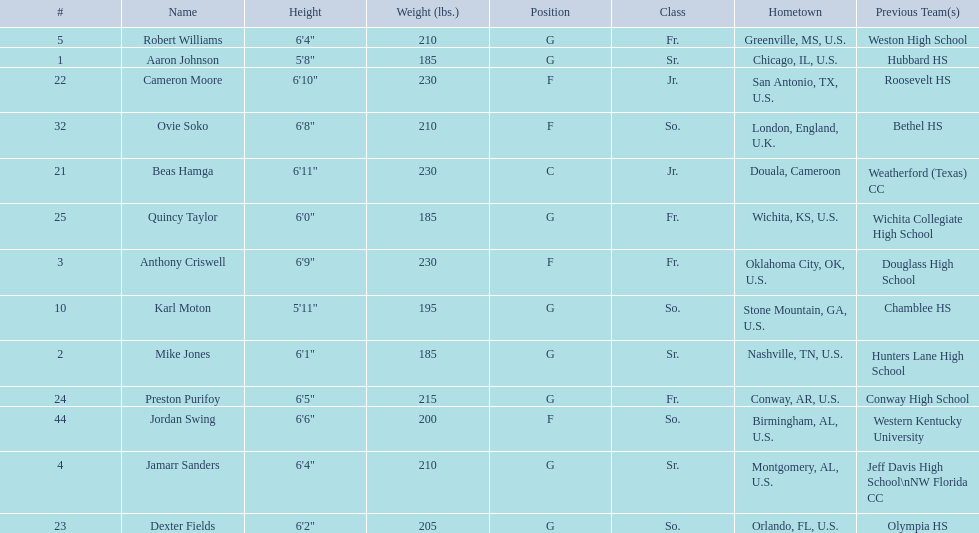How many total forwards are on the team? 4. Could you help me parse every detail presented in this table? {'header': ['#', 'Name', 'Height', 'Weight (lbs.)', 'Position', 'Class', 'Hometown', 'Previous Team(s)'], 'rows': [['5', 'Robert Williams', '6\'4"', '210', 'G', 'Fr.', 'Greenville, MS, U.S.', 'Weston High School'], ['1', 'Aaron Johnson', '5\'8"', '185', 'G', 'Sr.', 'Chicago, IL, U.S.', 'Hubbard HS'], ['22', 'Cameron Moore', '6\'10"', '230', 'F', 'Jr.', 'San Antonio, TX, U.S.', 'Roosevelt HS'], ['32', 'Ovie Soko', '6\'8"', '210', 'F', 'So.', 'London, England, U.K.', 'Bethel HS'], ['21', 'Beas Hamga', '6\'11"', '230', 'C', 'Jr.', 'Douala, Cameroon', 'Weatherford (Texas) CC'], ['25', 'Quincy Taylor', '6\'0"', '185', 'G', 'Fr.', 'Wichita, KS, U.S.', 'Wichita Collegiate High School'], ['3', 'Anthony Criswell', '6\'9"', '230', 'F', 'Fr.', 'Oklahoma City, OK, U.S.', 'Douglass High School'], ['10', 'Karl Moton', '5\'11"', '195', 'G', 'So.', 'Stone Mountain, GA, U.S.', 'Chamblee HS'], ['2', 'Mike Jones', '6\'1"', '185', 'G', 'Sr.', 'Nashville, TN, U.S.', 'Hunters Lane High School'], ['24', 'Preston Purifoy', '6\'5"', '215', 'G', 'Fr.', 'Conway, AR, U.S.', 'Conway High School'], ['44', 'Jordan Swing', '6\'6"', '200', 'F', 'So.', 'Birmingham, AL, U.S.', 'Western Kentucky University'], ['4', 'Jamarr Sanders', '6\'4"', '210', 'G', 'Sr.', 'Montgomery, AL, U.S.', 'Jeff Davis High School\\nNW Florida CC'], ['23', 'Dexter Fields', '6\'2"', '205', 'G', 'So.', 'Orlando, FL, U.S.', 'Olympia HS']]} 